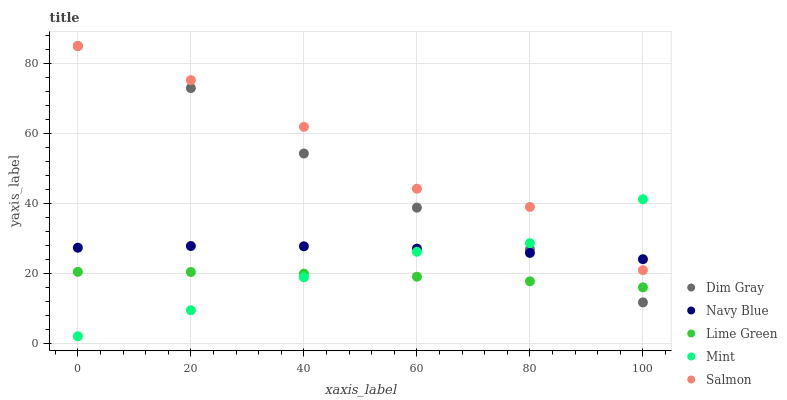Does Lime Green have the minimum area under the curve?
Answer yes or no. Yes. Does Salmon have the maximum area under the curve?
Answer yes or no. Yes. Does Dim Gray have the minimum area under the curve?
Answer yes or no. No. Does Dim Gray have the maximum area under the curve?
Answer yes or no. No. Is Lime Green the smoothest?
Answer yes or no. Yes. Is Salmon the roughest?
Answer yes or no. Yes. Is Dim Gray the smoothest?
Answer yes or no. No. Is Dim Gray the roughest?
Answer yes or no. No. Does Mint have the lowest value?
Answer yes or no. Yes. Does Dim Gray have the lowest value?
Answer yes or no. No. Does Salmon have the highest value?
Answer yes or no. Yes. Does Lime Green have the highest value?
Answer yes or no. No. Is Lime Green less than Salmon?
Answer yes or no. Yes. Is Salmon greater than Lime Green?
Answer yes or no. Yes. Does Mint intersect Salmon?
Answer yes or no. Yes. Is Mint less than Salmon?
Answer yes or no. No. Is Mint greater than Salmon?
Answer yes or no. No. Does Lime Green intersect Salmon?
Answer yes or no. No. 